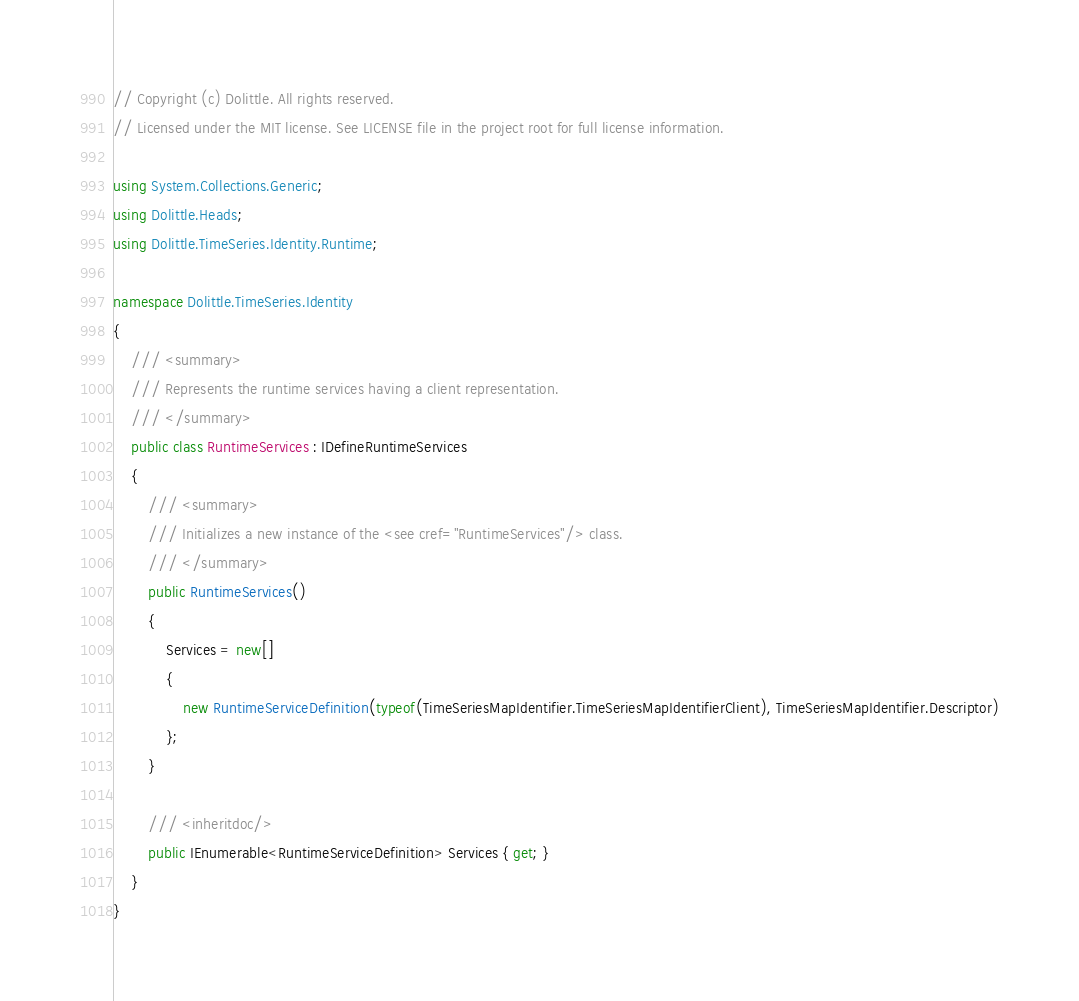<code> <loc_0><loc_0><loc_500><loc_500><_C#_>// Copyright (c) Dolittle. All rights reserved.
// Licensed under the MIT license. See LICENSE file in the project root for full license information.

using System.Collections.Generic;
using Dolittle.Heads;
using Dolittle.TimeSeries.Identity.Runtime;

namespace Dolittle.TimeSeries.Identity
{
    /// <summary>
    /// Represents the runtime services having a client representation.
    /// </summary>
    public class RuntimeServices : IDefineRuntimeServices
    {
        /// <summary>
        /// Initializes a new instance of the <see cref="RuntimeServices"/> class.
        /// </summary>
        public RuntimeServices()
        {
            Services = new[]
            {
                new RuntimeServiceDefinition(typeof(TimeSeriesMapIdentifier.TimeSeriesMapIdentifierClient), TimeSeriesMapIdentifier.Descriptor)
            };
        }

        /// <inheritdoc/>
        public IEnumerable<RuntimeServiceDefinition> Services { get; }
    }
}</code> 